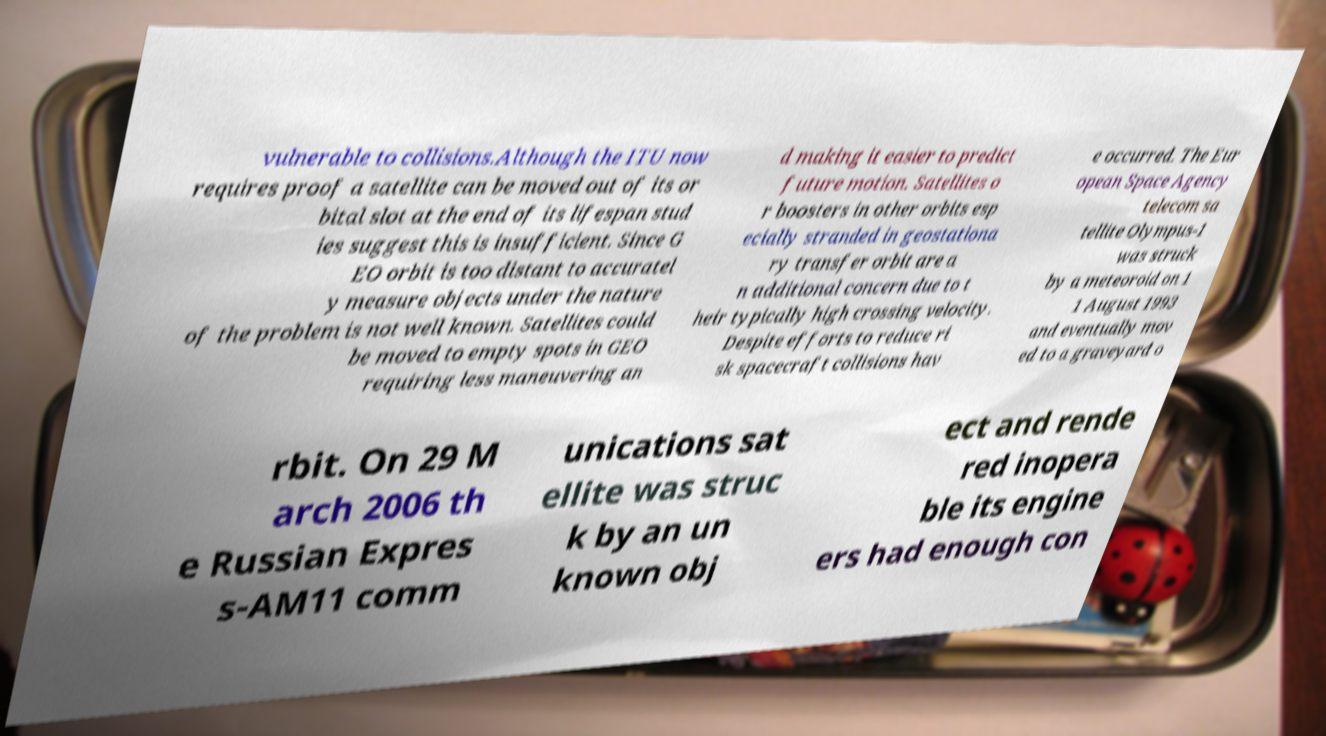Can you accurately transcribe the text from the provided image for me? vulnerable to collisions.Although the ITU now requires proof a satellite can be moved out of its or bital slot at the end of its lifespan stud ies suggest this is insufficient. Since G EO orbit is too distant to accuratel y measure objects under the nature of the problem is not well known. Satellites could be moved to empty spots in GEO requiring less maneuvering an d making it easier to predict future motion. Satellites o r boosters in other orbits esp ecially stranded in geostationa ry transfer orbit are a n additional concern due to t heir typically high crossing velocity. Despite efforts to reduce ri sk spacecraft collisions hav e occurred. The Eur opean Space Agency telecom sa tellite Olympus-1 was struck by a meteoroid on 1 1 August 1993 and eventually mov ed to a graveyard o rbit. On 29 M arch 2006 th e Russian Expres s-AM11 comm unications sat ellite was struc k by an un known obj ect and rende red inopera ble its engine ers had enough con 